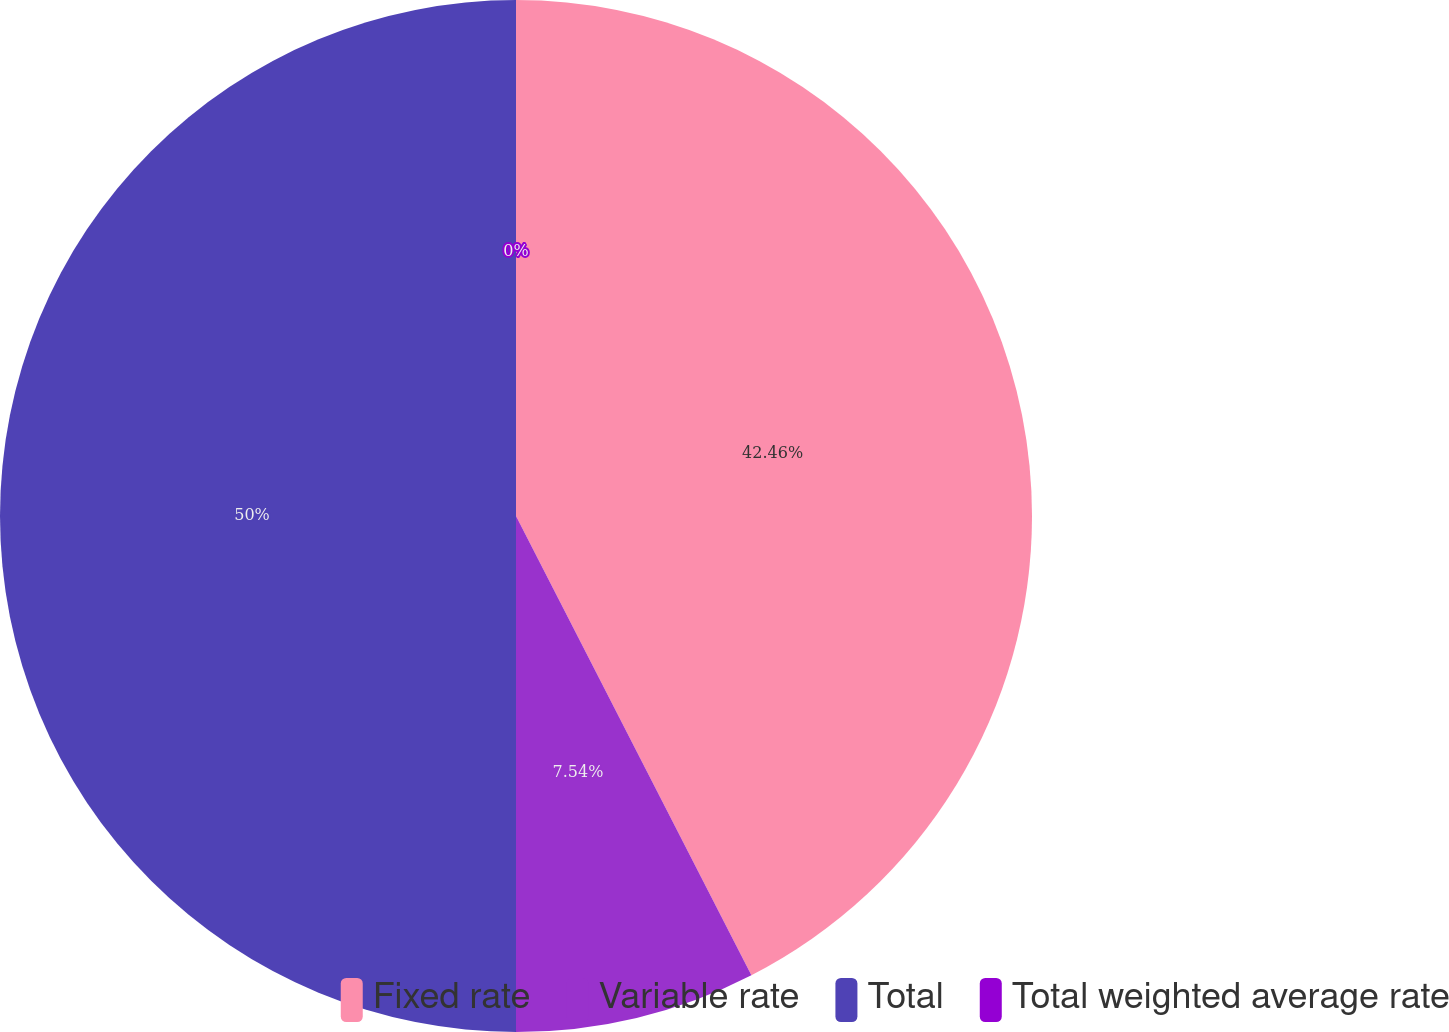Convert chart to OTSL. <chart><loc_0><loc_0><loc_500><loc_500><pie_chart><fcel>Fixed rate<fcel>Variable rate<fcel>Total<fcel>Total weighted average rate<nl><fcel>42.46%<fcel>7.54%<fcel>50.0%<fcel>0.0%<nl></chart> 